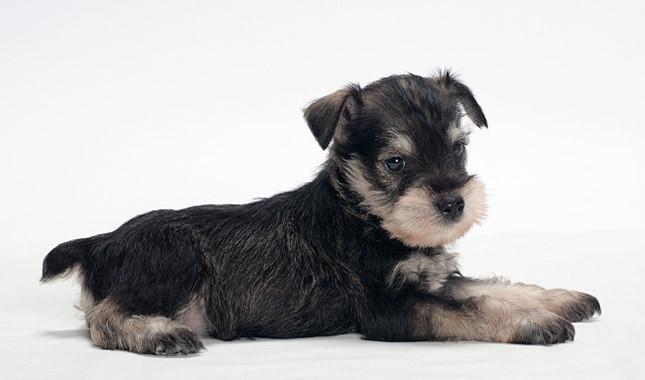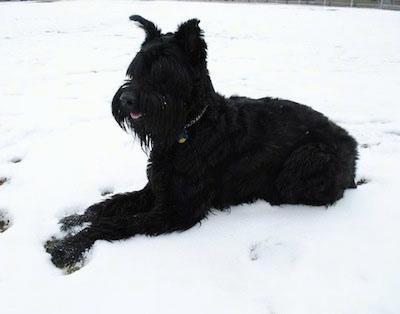The first image is the image on the left, the second image is the image on the right. Assess this claim about the two images: "The dogs are facing generally in the opposite direction". Correct or not? Answer yes or no. Yes. The first image is the image on the left, the second image is the image on the right. Evaluate the accuracy of this statement regarding the images: "An image shows a standing schnauzer dog posed with dog food.". Is it true? Answer yes or no. No. 